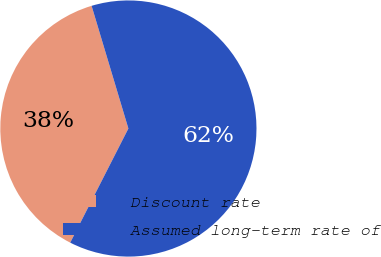Convert chart to OTSL. <chart><loc_0><loc_0><loc_500><loc_500><pie_chart><fcel>Discount rate<fcel>Assumed long-term rate of<nl><fcel>37.86%<fcel>62.14%<nl></chart> 